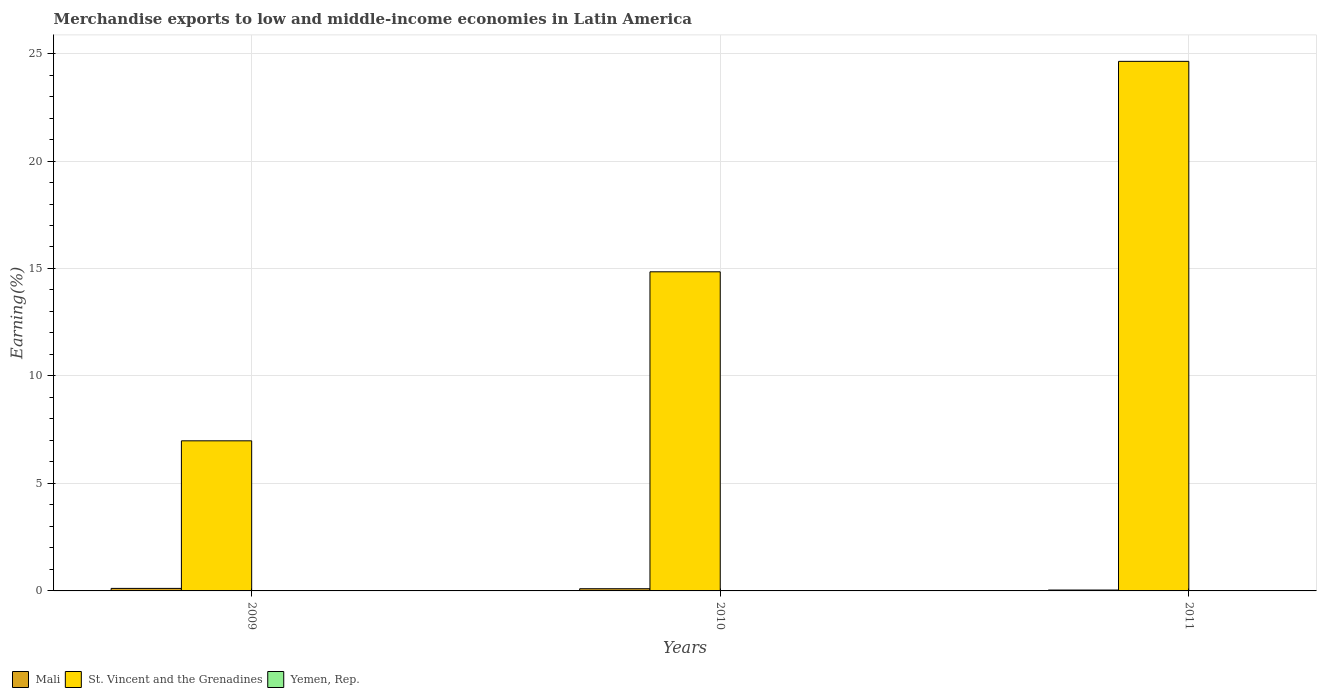Are the number of bars per tick equal to the number of legend labels?
Make the answer very short. Yes. What is the label of the 3rd group of bars from the left?
Offer a very short reply. 2011. In how many cases, is the number of bars for a given year not equal to the number of legend labels?
Keep it short and to the point. 0. What is the percentage of amount earned from merchandise exports in Mali in 2011?
Provide a short and direct response. 0.04. Across all years, what is the maximum percentage of amount earned from merchandise exports in St. Vincent and the Grenadines?
Make the answer very short. 24.64. Across all years, what is the minimum percentage of amount earned from merchandise exports in Mali?
Make the answer very short. 0.04. What is the total percentage of amount earned from merchandise exports in Mali in the graph?
Offer a very short reply. 0.26. What is the difference between the percentage of amount earned from merchandise exports in Yemen, Rep. in 2010 and that in 2011?
Keep it short and to the point. -3.140149816957018e-5. What is the difference between the percentage of amount earned from merchandise exports in Mali in 2011 and the percentage of amount earned from merchandise exports in St. Vincent and the Grenadines in 2009?
Provide a succinct answer. -6.94. What is the average percentage of amount earned from merchandise exports in Mali per year?
Your answer should be very brief. 0.09. In the year 2009, what is the difference between the percentage of amount earned from merchandise exports in St. Vincent and the Grenadines and percentage of amount earned from merchandise exports in Yemen, Rep.?
Your answer should be very brief. 6.98. In how many years, is the percentage of amount earned from merchandise exports in Mali greater than 3 %?
Offer a very short reply. 0. What is the ratio of the percentage of amount earned from merchandise exports in Yemen, Rep. in 2010 to that in 2011?
Offer a very short reply. 0.99. Is the percentage of amount earned from merchandise exports in Yemen, Rep. in 2009 less than that in 2010?
Make the answer very short. No. Is the difference between the percentage of amount earned from merchandise exports in St. Vincent and the Grenadines in 2010 and 2011 greater than the difference between the percentage of amount earned from merchandise exports in Yemen, Rep. in 2010 and 2011?
Provide a short and direct response. No. What is the difference between the highest and the second highest percentage of amount earned from merchandise exports in Mali?
Ensure brevity in your answer.  0.02. What is the difference between the highest and the lowest percentage of amount earned from merchandise exports in Yemen, Rep.?
Your answer should be very brief. 0. In how many years, is the percentage of amount earned from merchandise exports in Yemen, Rep. greater than the average percentage of amount earned from merchandise exports in Yemen, Rep. taken over all years?
Your answer should be very brief. 1. Is the sum of the percentage of amount earned from merchandise exports in St. Vincent and the Grenadines in 2009 and 2010 greater than the maximum percentage of amount earned from merchandise exports in Mali across all years?
Offer a very short reply. Yes. What does the 2nd bar from the left in 2009 represents?
Ensure brevity in your answer.  St. Vincent and the Grenadines. What does the 1st bar from the right in 2009 represents?
Your response must be concise. Yemen, Rep. What is the difference between two consecutive major ticks on the Y-axis?
Keep it short and to the point. 5. Where does the legend appear in the graph?
Ensure brevity in your answer.  Bottom left. How many legend labels are there?
Ensure brevity in your answer.  3. What is the title of the graph?
Offer a very short reply. Merchandise exports to low and middle-income economies in Latin America. What is the label or title of the X-axis?
Offer a very short reply. Years. What is the label or title of the Y-axis?
Ensure brevity in your answer.  Earning(%). What is the Earning(%) in Mali in 2009?
Offer a terse response. 0.12. What is the Earning(%) of St. Vincent and the Grenadines in 2009?
Your response must be concise. 6.98. What is the Earning(%) of Yemen, Rep. in 2009?
Offer a very short reply. 0. What is the Earning(%) in Mali in 2010?
Your answer should be very brief. 0.1. What is the Earning(%) in St. Vincent and the Grenadines in 2010?
Provide a succinct answer. 14.85. What is the Earning(%) in Yemen, Rep. in 2010?
Provide a succinct answer. 0. What is the Earning(%) in Mali in 2011?
Provide a succinct answer. 0.04. What is the Earning(%) in St. Vincent and the Grenadines in 2011?
Keep it short and to the point. 24.64. What is the Earning(%) in Yemen, Rep. in 2011?
Keep it short and to the point. 0. Across all years, what is the maximum Earning(%) in Mali?
Provide a succinct answer. 0.12. Across all years, what is the maximum Earning(%) of St. Vincent and the Grenadines?
Offer a very short reply. 24.64. Across all years, what is the maximum Earning(%) of Yemen, Rep.?
Make the answer very short. 0. Across all years, what is the minimum Earning(%) in Mali?
Your response must be concise. 0.04. Across all years, what is the minimum Earning(%) of St. Vincent and the Grenadines?
Your answer should be compact. 6.98. Across all years, what is the minimum Earning(%) of Yemen, Rep.?
Your answer should be very brief. 0. What is the total Earning(%) in Mali in the graph?
Your answer should be compact. 0.26. What is the total Earning(%) of St. Vincent and the Grenadines in the graph?
Your answer should be compact. 46.47. What is the total Earning(%) of Yemen, Rep. in the graph?
Make the answer very short. 0.01. What is the difference between the Earning(%) in Mali in 2009 and that in 2010?
Give a very brief answer. 0.02. What is the difference between the Earning(%) in St. Vincent and the Grenadines in 2009 and that in 2010?
Your answer should be compact. -7.86. What is the difference between the Earning(%) in Yemen, Rep. in 2009 and that in 2010?
Keep it short and to the point. 0. What is the difference between the Earning(%) in Mali in 2009 and that in 2011?
Make the answer very short. 0.08. What is the difference between the Earning(%) of St. Vincent and the Grenadines in 2009 and that in 2011?
Offer a terse response. -17.65. What is the difference between the Earning(%) of Yemen, Rep. in 2009 and that in 2011?
Offer a terse response. 0. What is the difference between the Earning(%) in Mali in 2010 and that in 2011?
Give a very brief answer. 0.06. What is the difference between the Earning(%) in St. Vincent and the Grenadines in 2010 and that in 2011?
Provide a succinct answer. -9.79. What is the difference between the Earning(%) in Mali in 2009 and the Earning(%) in St. Vincent and the Grenadines in 2010?
Your response must be concise. -14.73. What is the difference between the Earning(%) of Mali in 2009 and the Earning(%) of Yemen, Rep. in 2010?
Give a very brief answer. 0.12. What is the difference between the Earning(%) of St. Vincent and the Grenadines in 2009 and the Earning(%) of Yemen, Rep. in 2010?
Offer a very short reply. 6.98. What is the difference between the Earning(%) of Mali in 2009 and the Earning(%) of St. Vincent and the Grenadines in 2011?
Ensure brevity in your answer.  -24.52. What is the difference between the Earning(%) of Mali in 2009 and the Earning(%) of Yemen, Rep. in 2011?
Give a very brief answer. 0.12. What is the difference between the Earning(%) of St. Vincent and the Grenadines in 2009 and the Earning(%) of Yemen, Rep. in 2011?
Your response must be concise. 6.98. What is the difference between the Earning(%) in Mali in 2010 and the Earning(%) in St. Vincent and the Grenadines in 2011?
Give a very brief answer. -24.53. What is the difference between the Earning(%) in Mali in 2010 and the Earning(%) in Yemen, Rep. in 2011?
Your answer should be very brief. 0.1. What is the difference between the Earning(%) in St. Vincent and the Grenadines in 2010 and the Earning(%) in Yemen, Rep. in 2011?
Make the answer very short. 14.84. What is the average Earning(%) in Mali per year?
Make the answer very short. 0.09. What is the average Earning(%) in St. Vincent and the Grenadines per year?
Offer a terse response. 15.49. What is the average Earning(%) in Yemen, Rep. per year?
Provide a short and direct response. 0. In the year 2009, what is the difference between the Earning(%) of Mali and Earning(%) of St. Vincent and the Grenadines?
Provide a succinct answer. -6.87. In the year 2009, what is the difference between the Earning(%) of Mali and Earning(%) of Yemen, Rep.?
Your answer should be compact. 0.11. In the year 2009, what is the difference between the Earning(%) in St. Vincent and the Grenadines and Earning(%) in Yemen, Rep.?
Make the answer very short. 6.98. In the year 2010, what is the difference between the Earning(%) of Mali and Earning(%) of St. Vincent and the Grenadines?
Offer a very short reply. -14.74. In the year 2010, what is the difference between the Earning(%) of Mali and Earning(%) of Yemen, Rep.?
Give a very brief answer. 0.1. In the year 2010, what is the difference between the Earning(%) in St. Vincent and the Grenadines and Earning(%) in Yemen, Rep.?
Your answer should be very brief. 14.84. In the year 2011, what is the difference between the Earning(%) in Mali and Earning(%) in St. Vincent and the Grenadines?
Provide a short and direct response. -24.6. In the year 2011, what is the difference between the Earning(%) in Mali and Earning(%) in Yemen, Rep.?
Make the answer very short. 0.04. In the year 2011, what is the difference between the Earning(%) of St. Vincent and the Grenadines and Earning(%) of Yemen, Rep.?
Your answer should be very brief. 24.63. What is the ratio of the Earning(%) in Mali in 2009 to that in 2010?
Your answer should be compact. 1.15. What is the ratio of the Earning(%) in St. Vincent and the Grenadines in 2009 to that in 2010?
Provide a succinct answer. 0.47. What is the ratio of the Earning(%) of Yemen, Rep. in 2009 to that in 2010?
Give a very brief answer. 1.42. What is the ratio of the Earning(%) in Mali in 2009 to that in 2011?
Ensure brevity in your answer.  2.85. What is the ratio of the Earning(%) in St. Vincent and the Grenadines in 2009 to that in 2011?
Make the answer very short. 0.28. What is the ratio of the Earning(%) of Yemen, Rep. in 2009 to that in 2011?
Ensure brevity in your answer.  1.4. What is the ratio of the Earning(%) of Mali in 2010 to that in 2011?
Make the answer very short. 2.48. What is the ratio of the Earning(%) in St. Vincent and the Grenadines in 2010 to that in 2011?
Your response must be concise. 0.6. What is the ratio of the Earning(%) in Yemen, Rep. in 2010 to that in 2011?
Offer a terse response. 0.99. What is the difference between the highest and the second highest Earning(%) of Mali?
Offer a terse response. 0.02. What is the difference between the highest and the second highest Earning(%) in St. Vincent and the Grenadines?
Offer a terse response. 9.79. What is the difference between the highest and the second highest Earning(%) in Yemen, Rep.?
Give a very brief answer. 0. What is the difference between the highest and the lowest Earning(%) of Mali?
Make the answer very short. 0.08. What is the difference between the highest and the lowest Earning(%) in St. Vincent and the Grenadines?
Provide a short and direct response. 17.65. What is the difference between the highest and the lowest Earning(%) in Yemen, Rep.?
Offer a very short reply. 0. 